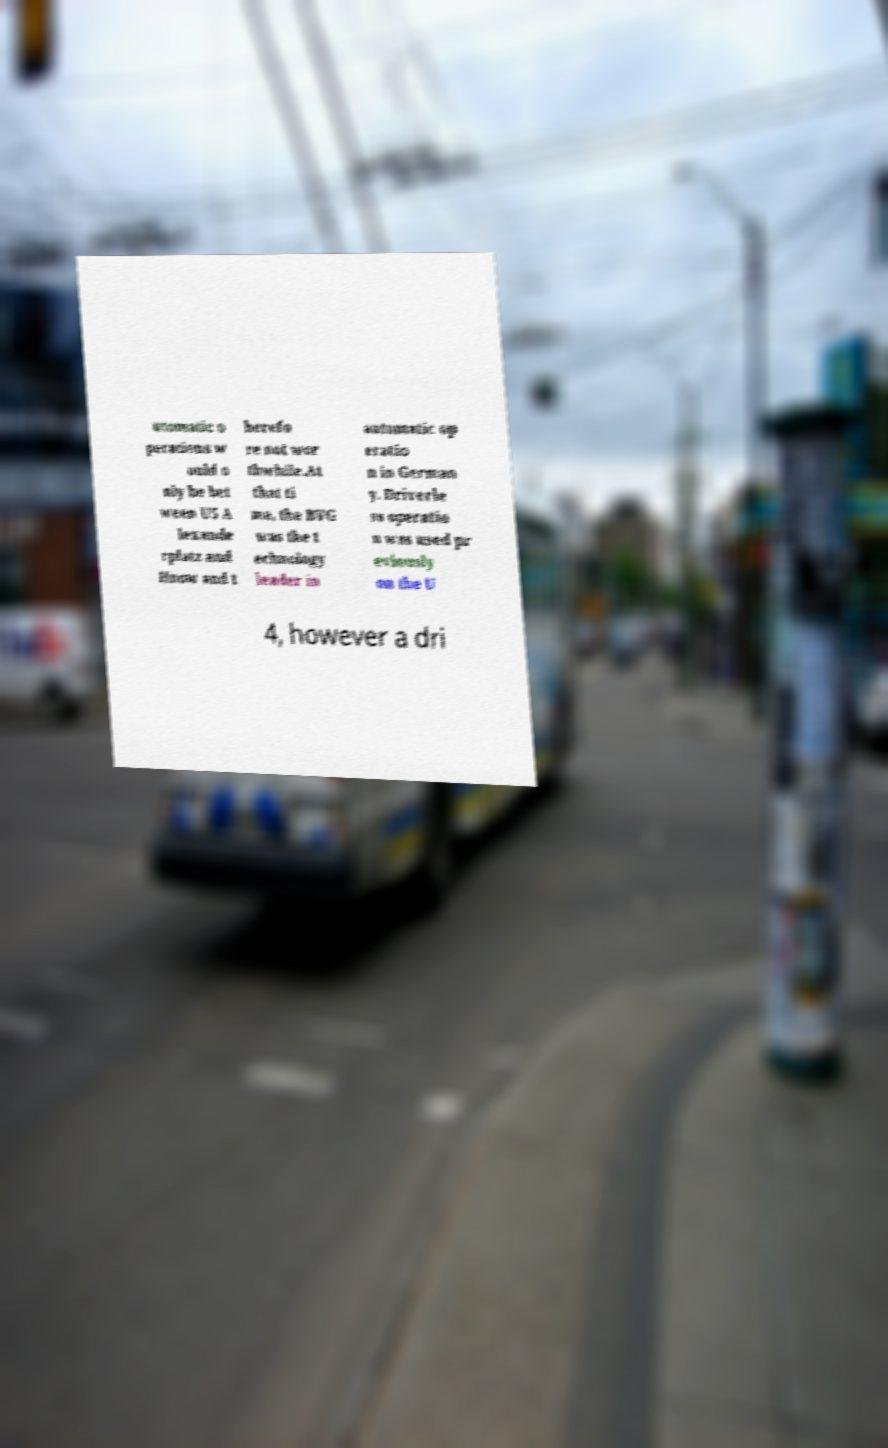What messages or text are displayed in this image? I need them in a readable, typed format. utomatic o perations w ould o nly be bet ween U5 A lexande rplatz and Hnow and t herefo re not wor thwhile.At that ti me, the BVG was the t echnology leader in automatic op eratio n in German y. Driverle ss operatio n was used pr eviously on the U 4, however a dri 